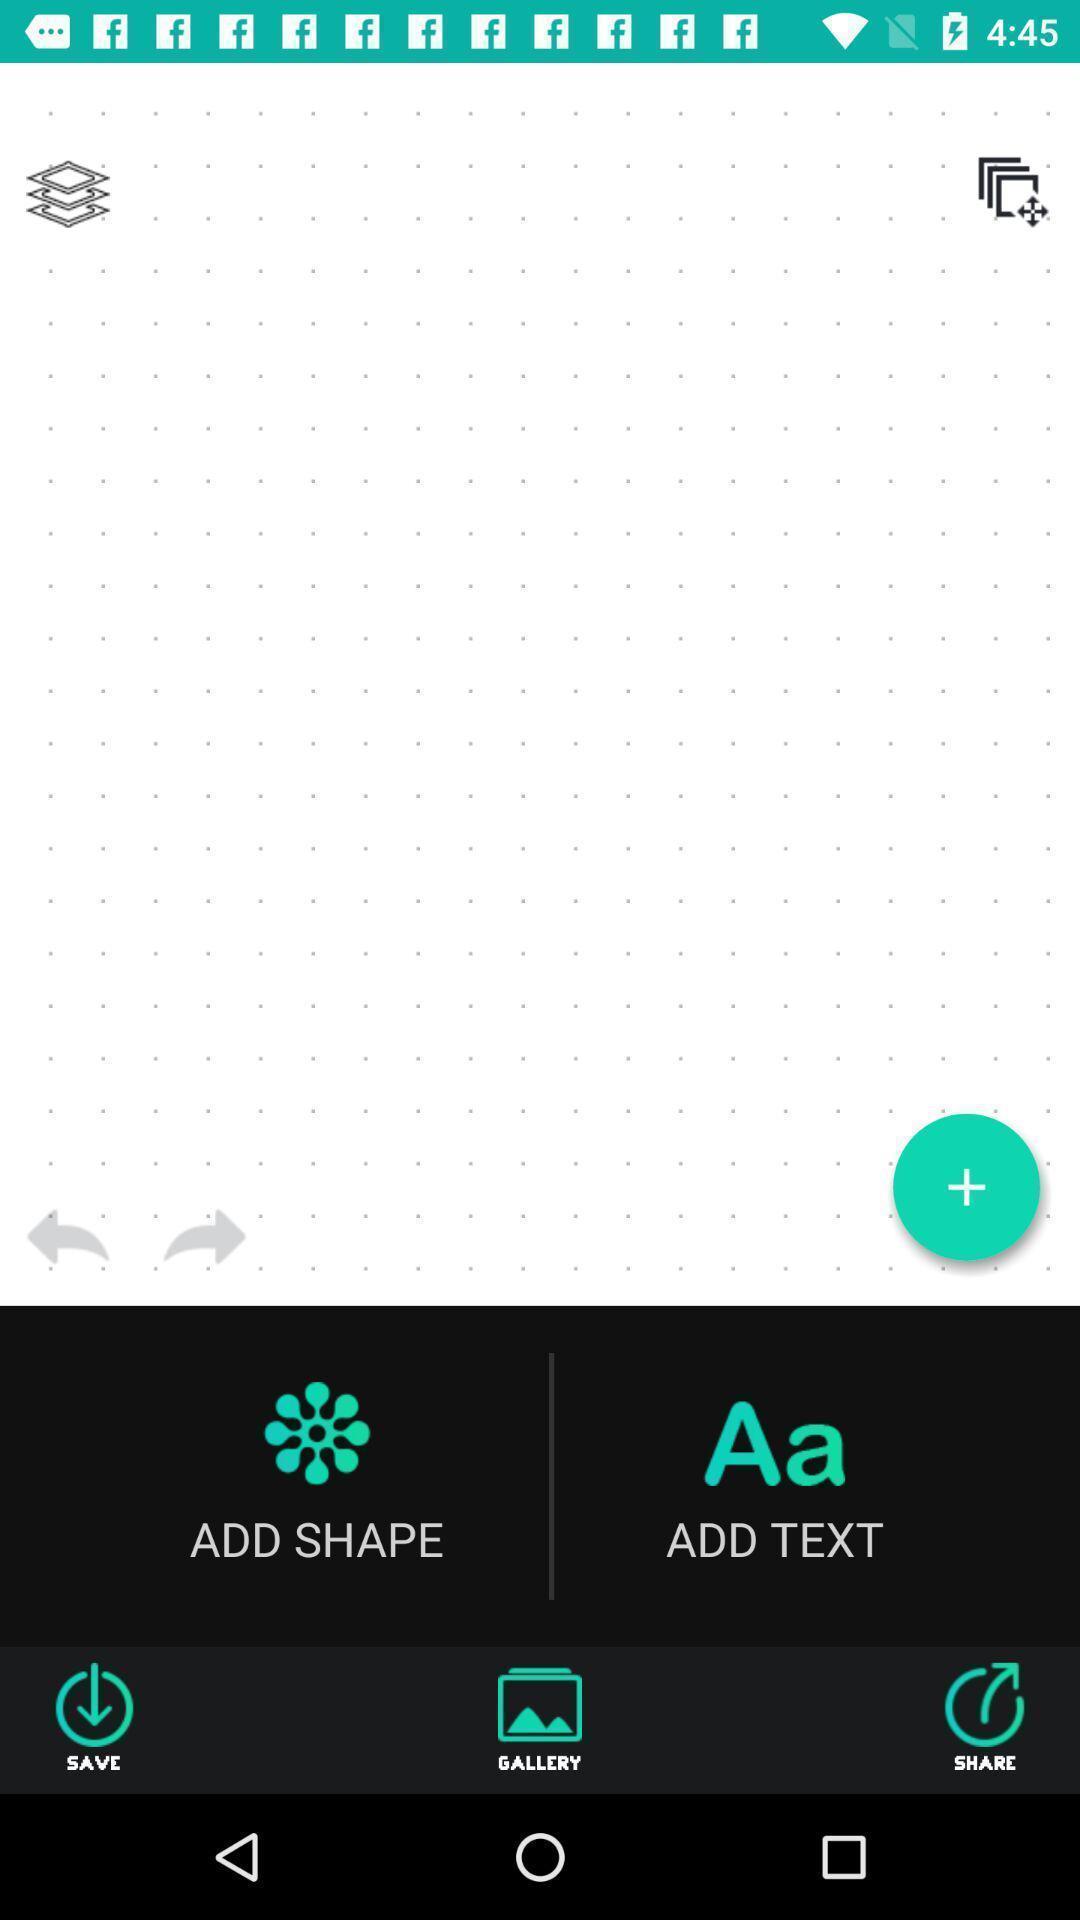Describe the visual elements of this screenshot. Screen shows multiple options in a design application. 